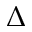Convert formula to latex. <formula><loc_0><loc_0><loc_500><loc_500>\Delta</formula> 